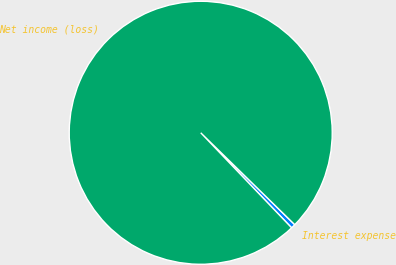<chart> <loc_0><loc_0><loc_500><loc_500><pie_chart><fcel>Interest expense<fcel>Net income (loss)<nl><fcel>0.54%<fcel>99.46%<nl></chart> 